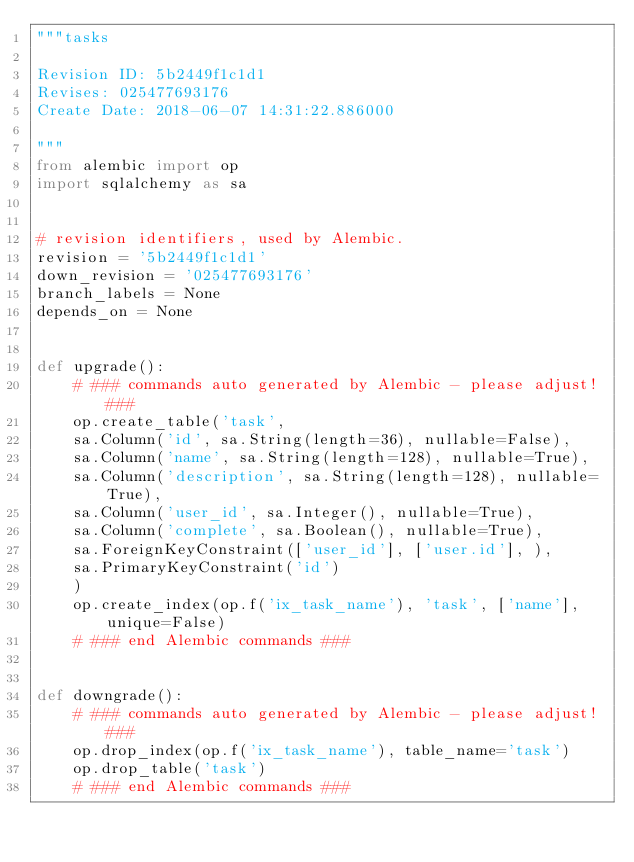<code> <loc_0><loc_0><loc_500><loc_500><_Python_>"""tasks

Revision ID: 5b2449f1c1d1
Revises: 025477693176
Create Date: 2018-06-07 14:31:22.886000

"""
from alembic import op
import sqlalchemy as sa


# revision identifiers, used by Alembic.
revision = '5b2449f1c1d1'
down_revision = '025477693176'
branch_labels = None
depends_on = None


def upgrade():
    # ### commands auto generated by Alembic - please adjust! ###
    op.create_table('task',
    sa.Column('id', sa.String(length=36), nullable=False),
    sa.Column('name', sa.String(length=128), nullable=True),
    sa.Column('description', sa.String(length=128), nullable=True),
    sa.Column('user_id', sa.Integer(), nullable=True),
    sa.Column('complete', sa.Boolean(), nullable=True),
    sa.ForeignKeyConstraint(['user_id'], ['user.id'], ),
    sa.PrimaryKeyConstraint('id')
    )
    op.create_index(op.f('ix_task_name'), 'task', ['name'], unique=False)
    # ### end Alembic commands ###


def downgrade():
    # ### commands auto generated by Alembic - please adjust! ###
    op.drop_index(op.f('ix_task_name'), table_name='task')
    op.drop_table('task')
    # ### end Alembic commands ###
</code> 